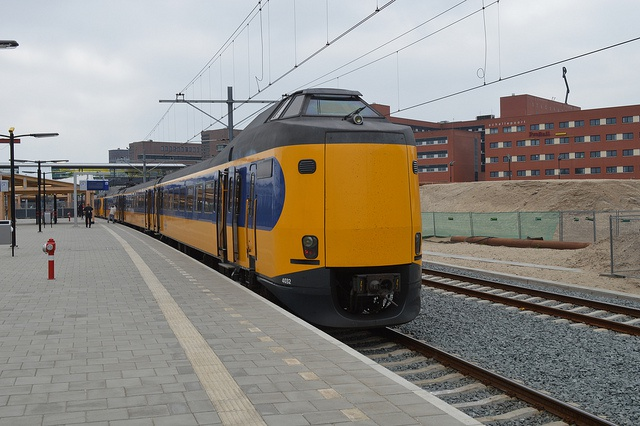Describe the objects in this image and their specific colors. I can see train in lightgray, orange, black, gray, and navy tones, fire hydrant in lightgray, maroon, darkgray, gray, and brown tones, people in lightgray, black, gray, maroon, and brown tones, people in lightgray, gray, darkgray, and black tones, and fire hydrant in lightgray, maroon, gray, and black tones in this image. 